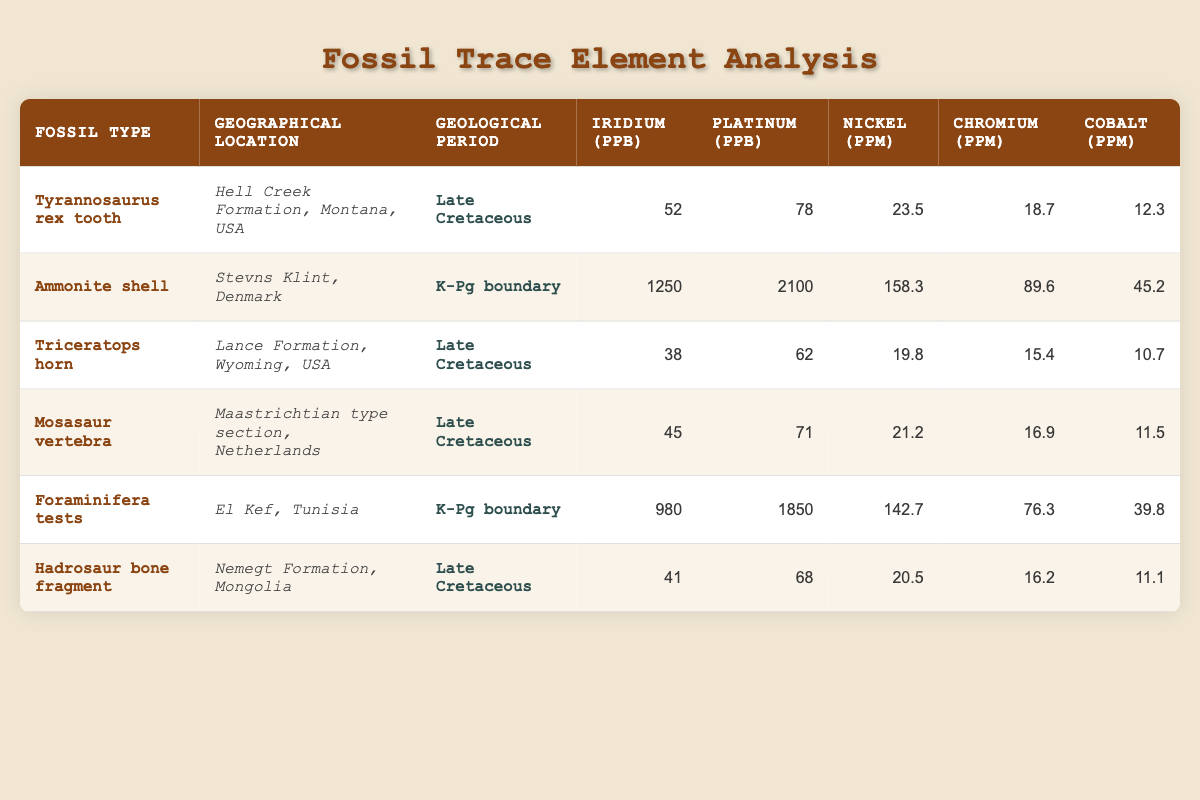What is the highest concentration of Iridium recorded in the table? From the table, we can see that the Ammonite shell has the highest concentration of Iridium at 1250 ppb.
Answer: 1250 ppb Which fossil type has the lowest Nickel concentration? The Triceratops horn has the lowest Nickel concentration at 19.8 ppm when compared to others like the Mosasaur vertebra, which has 21.2 ppm, and the Tyrannosaurus rex tooth, which has 23.5 ppm.
Answer: Triceratops horn What is the average concentration of Platinum for fossils from the K-Pg boundary? There are two fossils from the K-Pg boundary: the Ammonite shell (2100 ppb) and Foraminifera tests (1850 ppb). Adding these gives 2100 + 1850 = 3950 ppb. Dividing by 2 (the number of fossils) gives an average of 1975 ppb.
Answer: 1975 ppb Is the Cobalt concentration higher in the Tyrannosaurus rex tooth than in the Hadrosaur bone fragment? The Tyrannosaurus rex tooth has a Cobalt concentration of 12.3 ppm while the Hadrosaur bone fragment has 11.1 ppm. Since 12.3 is greater than 11.1, the statement is true.
Answer: Yes Which geographical location features fossils from the Late Cretaceous with the highest Chromium concentration? The Ammonite shell and the Foraminifera tests are from the K-Pg boundary; all Late Cretaceous fossils have lower Chromium levels. Among them, the Ammonite shell has 89.6 ppm, whereas the highest among Late Cretaceous fossils is the Tyrannosaurus rex tooth at 18.7 ppm. Thus, the Ammonite shell has the highest Chromium concentration overall.
Answer: Stevns Klint, Denmark 